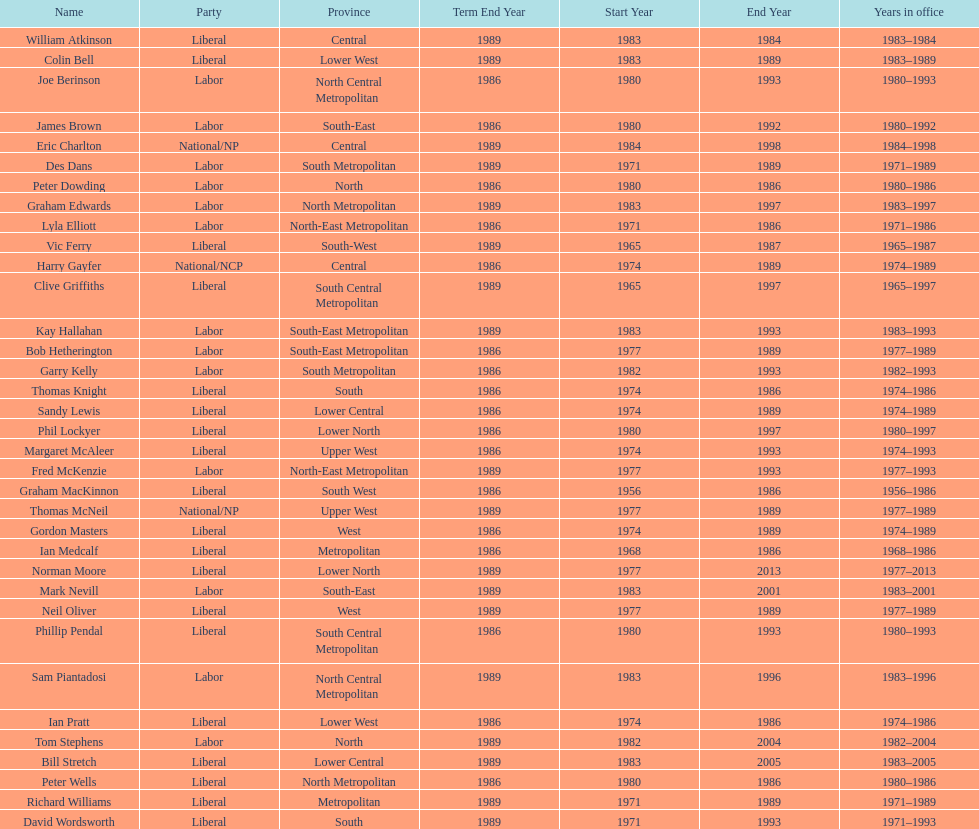Which party has the most membership? Liberal. 